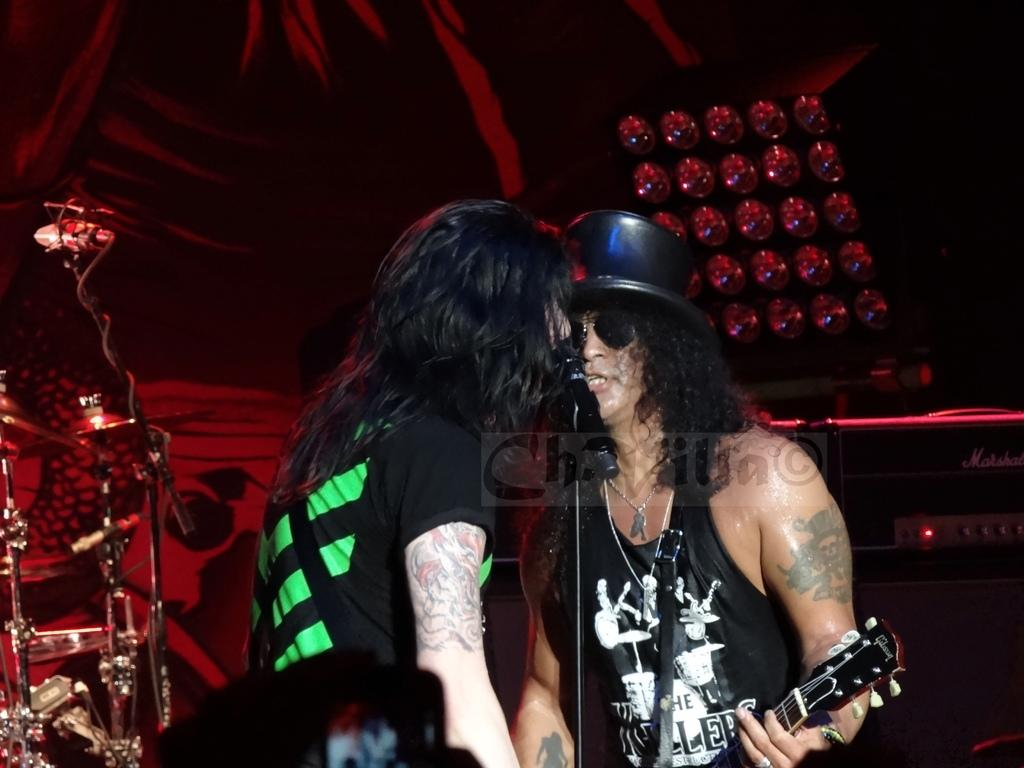How many people are in the image? There are two persons in the image. What are the persons doing in the image? The persons are standing and playing a musical instrument, and they are also singing. What can be seen in the image that is used for amplifying sound? There is a microphone in the image. What other musical instruments can be seen in the background of the image? There are other musical instruments in the background. What structure is visible in the background of the image? There is a tent in the background. What type of recess is visible in the image? There is no recess present in the image. How does the image produce music? The image itself does not produce music; it depicts people playing musical instruments and singing. 